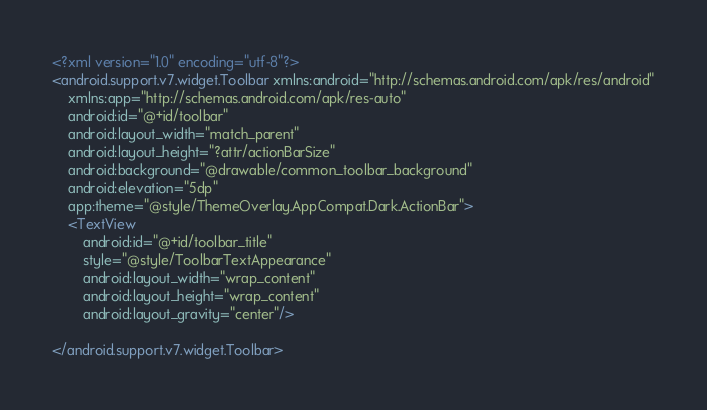Convert code to text. <code><loc_0><loc_0><loc_500><loc_500><_XML_><?xml version="1.0" encoding="utf-8"?>
<android.support.v7.widget.Toolbar xmlns:android="http://schemas.android.com/apk/res/android"
    xmlns:app="http://schemas.android.com/apk/res-auto"
    android:id="@+id/toolbar"
    android:layout_width="match_parent"
    android:layout_height="?attr/actionBarSize"
    android:background="@drawable/common_toolbar_background"
    android:elevation="5dp"
    app:theme="@style/ThemeOverlay.AppCompat.Dark.ActionBar">
    <TextView
        android:id="@+id/toolbar_title"
        style="@style/ToolbarTextAppearance"
        android:layout_width="wrap_content"
        android:layout_height="wrap_content"
        android:layout_gravity="center"/>

</android.support.v7.widget.Toolbar></code> 